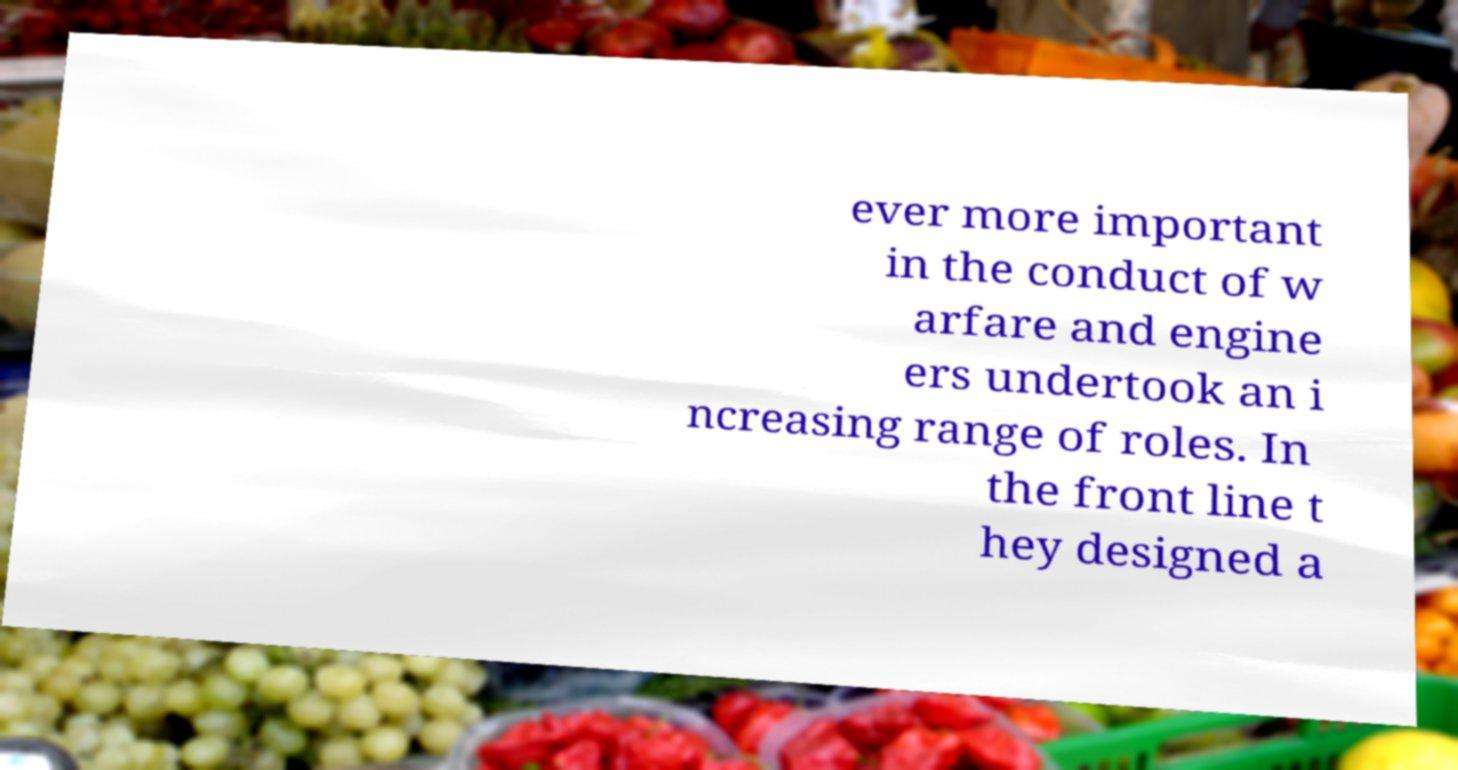Can you read and provide the text displayed in the image?This photo seems to have some interesting text. Can you extract and type it out for me? ever more important in the conduct of w arfare and engine ers undertook an i ncreasing range of roles. In the front line t hey designed a 